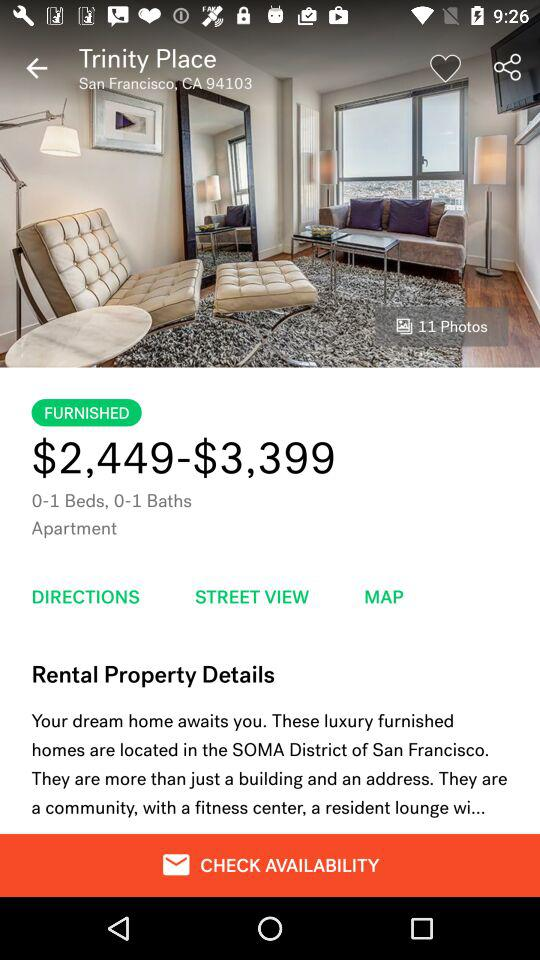What is the ZIP code? The ZIP code is 94103. 